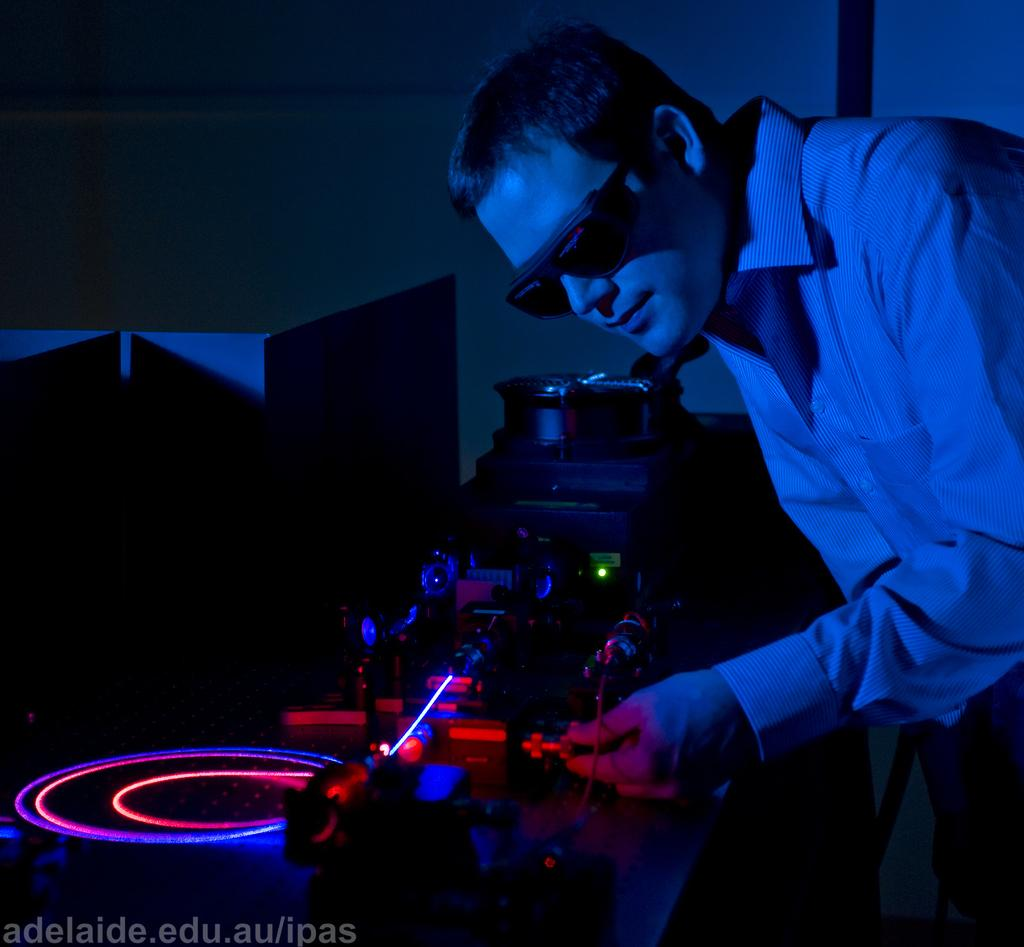Who or what is on the right side of the image? There is a person on the right side of the image. What is the main object in the middle of the image? There is an instrument in the middle of the image. What are the glowing objects on the left side of the image? There are ring-like objects glowing on the left side of the image. What can be seen in the background of the image? There is a wall visible in the background of the image. How does the person in the image perform addition with the instrument? There is no indication in the image that the person is performing addition or using the instrument for that purpose. 